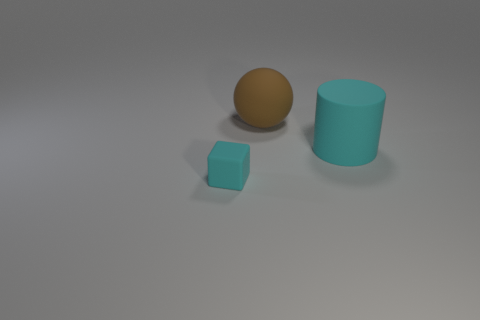Are there any other things that have the same size as the cube?
Offer a terse response. No. There is a matte object that is the same color as the cylinder; what shape is it?
Keep it short and to the point. Cube. What number of other objects are there of the same size as the brown object?
Your response must be concise. 1. Is the big object in front of the big brown ball made of the same material as the block?
Your answer should be compact. Yes. How many other objects are there of the same color as the rubber cylinder?
Ensure brevity in your answer.  1. How many other objects are there of the same shape as the brown matte thing?
Make the answer very short. 0. Do the cyan rubber thing that is to the right of the tiny cyan rubber object and the big thing to the left of the large cyan cylinder have the same shape?
Your response must be concise. No. Is the number of cyan objects that are on the left side of the cylinder the same as the number of rubber things behind the rubber cube?
Ensure brevity in your answer.  No. What shape is the cyan object on the right side of the cyan thing that is on the left side of the cyan rubber thing that is behind the tiny object?
Give a very brief answer. Cylinder. Does the object that is on the left side of the brown rubber sphere have the same material as the cyan thing that is behind the tiny matte block?
Provide a short and direct response. Yes. 